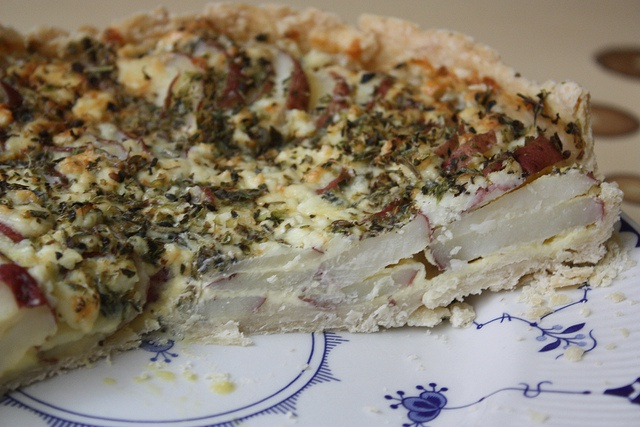Describe the objects in this image and their specific colors. I can see a pizza in gray, darkgray, olive, tan, and maroon tones in this image. 